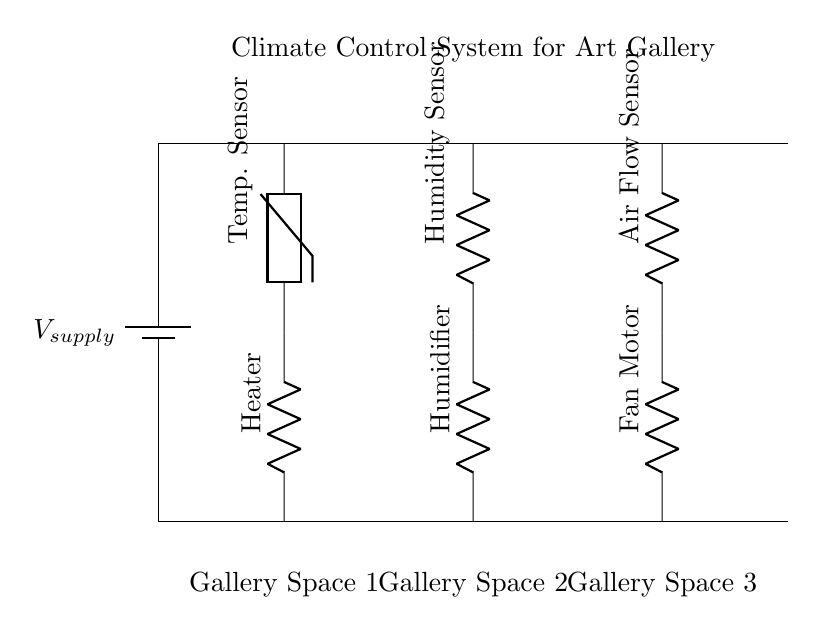What is the supply voltage for the circuit? The supply voltage is labeled as V_supply at the battery symbol, indicating the voltage provided to the circuit components.
Answer: V_supply How many branches are there in this climate control system? The diagram shows three distinct branches: a heater with a temperature sensor, a humidifier with a humidity sensor, and a fan motor with an airflow sensor. Each branch operates independently in parallel.
Answer: Three What component is used for maintaining temperature in Gallery Space 1? In Gallery Space 1, the component responsible for maintaining temperature is the heater, as identified in the temperature control branch.
Answer: Heater Which sensor is associated with the humidifier? The humidity sensor is directly connected to the humidifier in the second branch of the circuit, allowing it to monitor humidity levels.
Answer: Humidity Sensor What is the function of the fan motor in the system? The fan motor circulates air within the gallery, thus playing a crucial role in ventilation and keeping the temperature and humidity balanced across the spaces.
Answer: Ventilation How are the branches connected in this circuit? The branches are connected in parallel to the main power supply, meaning each component operates independently and can receive voltage independently from the supply.
Answer: Parallel 